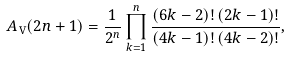<formula> <loc_0><loc_0><loc_500><loc_500>A _ { \mathrm V } ( 2 n + 1 ) = \frac { 1 } { 2 ^ { n } } \prod _ { k = 1 } ^ { n } \frac { ( 6 k - 2 ) ! \, ( 2 k - 1 ) ! } { ( 4 k - 1 ) ! \, ( 4 k - 2 ) ! } ,</formula> 